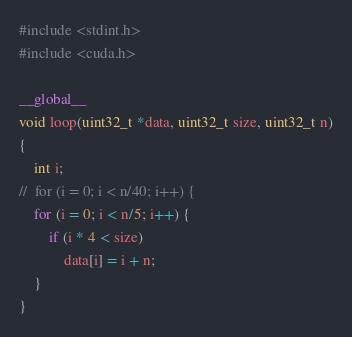Convert code to text. <code><loc_0><loc_0><loc_500><loc_500><_Cuda_>#include <stdint.h>
#include <cuda.h>

__global__
void loop(uint32_t *data, uint32_t size, uint32_t n)
{
    int i;
//	for (i = 0; i < n/40; i++) {
	for (i = 0; i < n/5; i++) {
		if (i * 4 < size)
			data[i] = i + n;
    }
}
</code> 